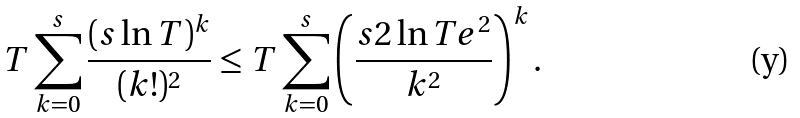<formula> <loc_0><loc_0><loc_500><loc_500>T \sum _ { k = 0 } ^ { s } \frac { ( s \ln T ) ^ { k } } { ( k ! ) ^ { 2 } } \leq T \sum _ { k = 0 } ^ { s } \left ( \frac { s 2 \ln T e ^ { 2 } } { k ^ { 2 } } \right ) ^ { k } .</formula> 